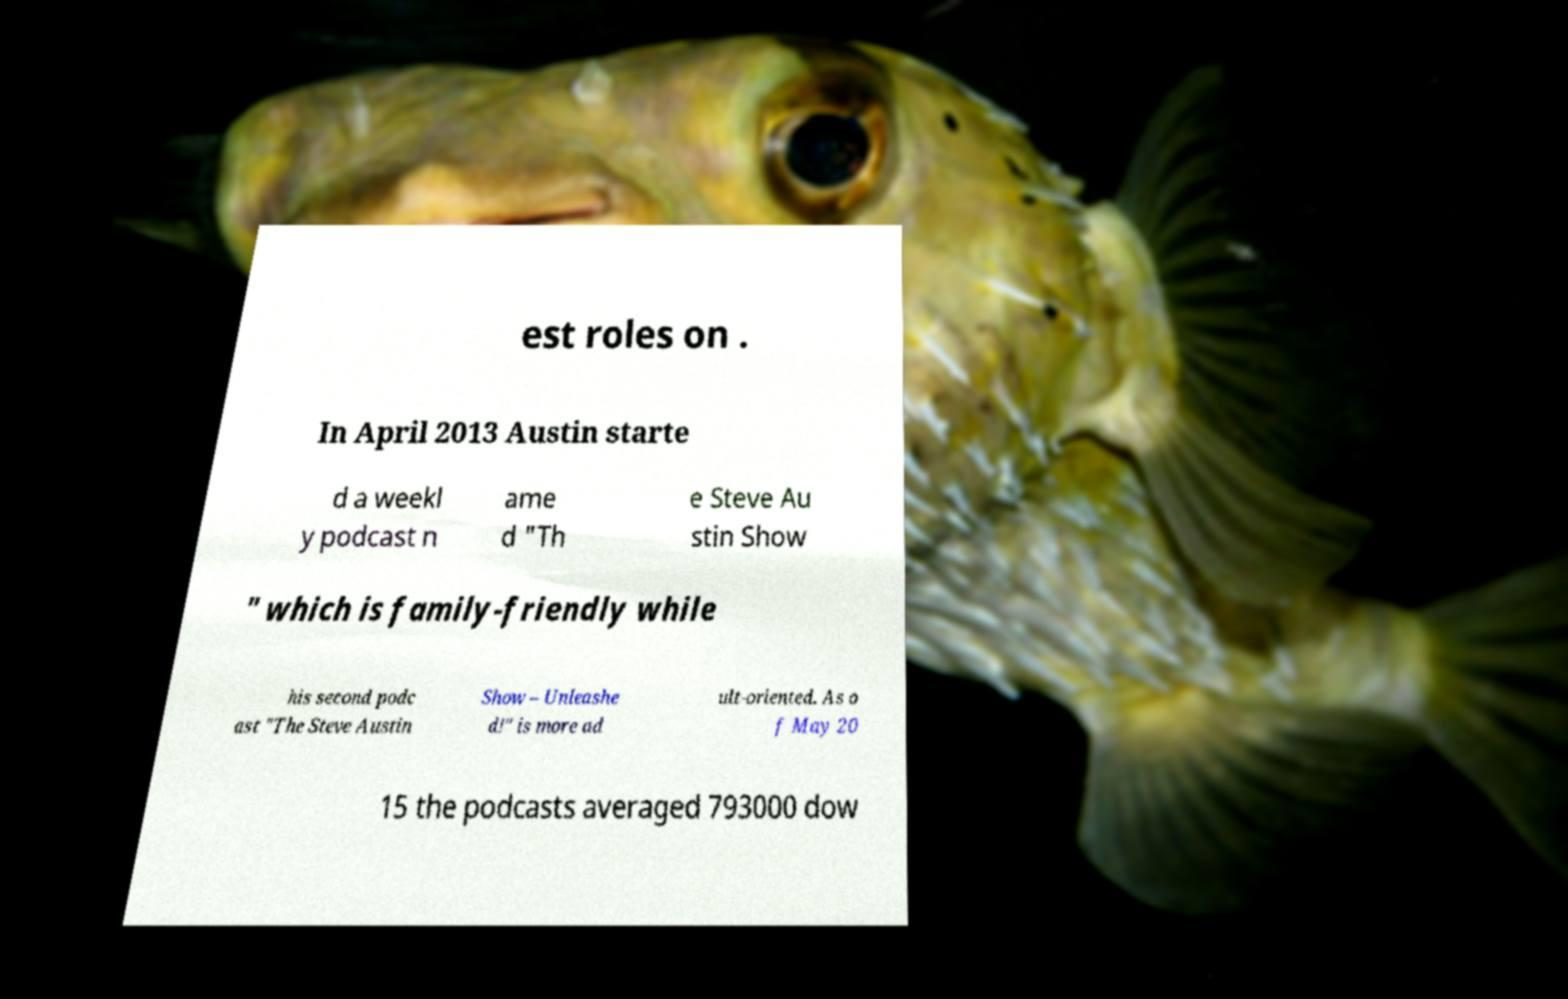Can you read and provide the text displayed in the image?This photo seems to have some interesting text. Can you extract and type it out for me? est roles on . In April 2013 Austin starte d a weekl y podcast n ame d "Th e Steve Au stin Show " which is family-friendly while his second podc ast "The Steve Austin Show – Unleashe d!" is more ad ult-oriented. As o f May 20 15 the podcasts averaged 793000 dow 